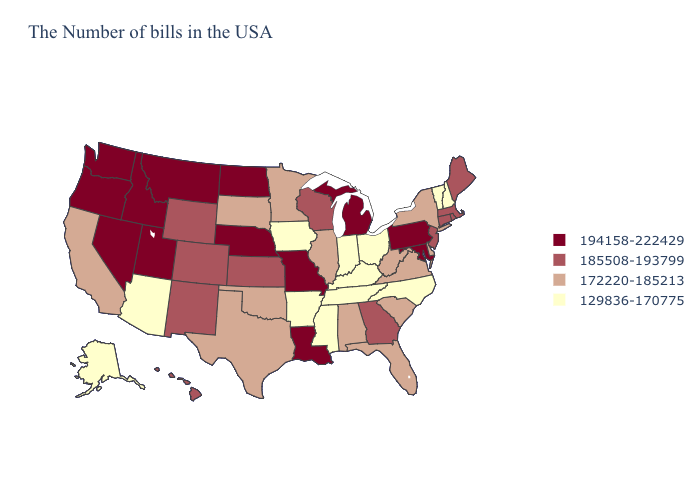Name the states that have a value in the range 185508-193799?
Quick response, please. Maine, Massachusetts, Rhode Island, Connecticut, New Jersey, Georgia, Wisconsin, Kansas, Wyoming, Colorado, New Mexico, Hawaii. What is the value of Michigan?
Short answer required. 194158-222429. Name the states that have a value in the range 194158-222429?
Concise answer only. Maryland, Pennsylvania, Michigan, Louisiana, Missouri, Nebraska, North Dakota, Utah, Montana, Idaho, Nevada, Washington, Oregon. What is the lowest value in the MidWest?
Quick response, please. 129836-170775. Does the map have missing data?
Quick response, please. No. Does the map have missing data?
Write a very short answer. No. Name the states that have a value in the range 172220-185213?
Concise answer only. New York, Delaware, Virginia, South Carolina, West Virginia, Florida, Alabama, Illinois, Minnesota, Oklahoma, Texas, South Dakota, California. What is the highest value in the MidWest ?
Concise answer only. 194158-222429. Does Missouri have the highest value in the USA?
Quick response, please. Yes. What is the value of North Carolina?
Answer briefly. 129836-170775. Among the states that border Tennessee , does Georgia have the lowest value?
Give a very brief answer. No. Name the states that have a value in the range 185508-193799?
Keep it brief. Maine, Massachusetts, Rhode Island, Connecticut, New Jersey, Georgia, Wisconsin, Kansas, Wyoming, Colorado, New Mexico, Hawaii. What is the value of New Hampshire?
Give a very brief answer. 129836-170775. Among the states that border Pennsylvania , does West Virginia have the lowest value?
Keep it brief. No. Name the states that have a value in the range 129836-170775?
Be succinct. New Hampshire, Vermont, North Carolina, Ohio, Kentucky, Indiana, Tennessee, Mississippi, Arkansas, Iowa, Arizona, Alaska. 